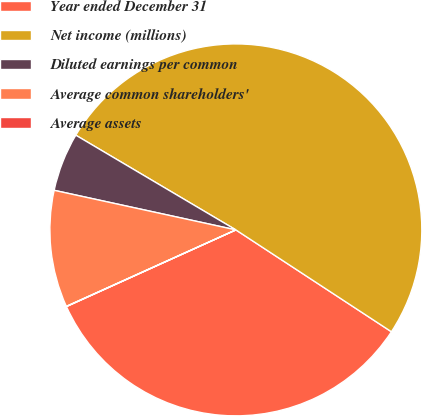<chart> <loc_0><loc_0><loc_500><loc_500><pie_chart><fcel>Year ended December 31<fcel>Net income (millions)<fcel>Diluted earnings per common<fcel>Average common shareholders'<fcel>Average assets<nl><fcel>34.01%<fcel>50.73%<fcel>5.09%<fcel>10.16%<fcel>0.02%<nl></chart> 